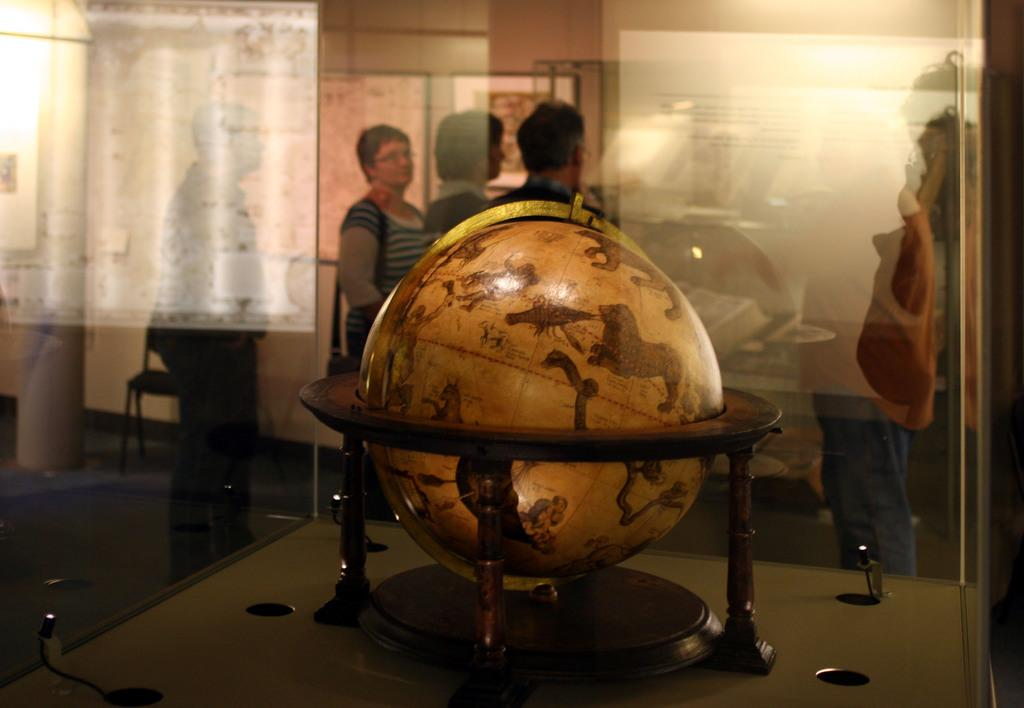What is the main object in the image? There is a globe in a glass box in the image. What can be seen in the background of the image? There are people standing and a chair in the background of the image. What is attached to the wall in the background of the image? There are photo frames attached to the wall in the background of the image. What type of dress is the carriage wearing in the image? There is no carriage or dress present in the image. How many friends are visible in the image? The image does not show any friends; it only shows people standing in the background. 